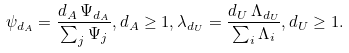Convert formula to latex. <formula><loc_0><loc_0><loc_500><loc_500>\psi _ { d _ { A } } = \frac { d _ { A } \, \Psi _ { d _ { A } } } { \sum _ { j } \Psi _ { j } } , d _ { A } \geq 1 , \lambda _ { d _ { U } } = \frac { d _ { U } \, \Lambda _ { d _ { U } } } { \sum _ { i } \Lambda _ { i } } , d _ { U } \geq 1 .</formula> 